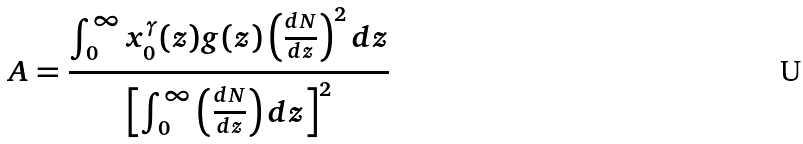<formula> <loc_0><loc_0><loc_500><loc_500>A = \frac { \int _ { 0 } ^ { \infty } x _ { 0 } ^ { \gamma } ( z ) g ( z ) \left ( \frac { d N } { d z } \right ) ^ { 2 } d z } { \left [ \int _ { 0 } ^ { \infty } \left ( \frac { d N } { d z } \right ) d z \right ] ^ { 2 } }</formula> 